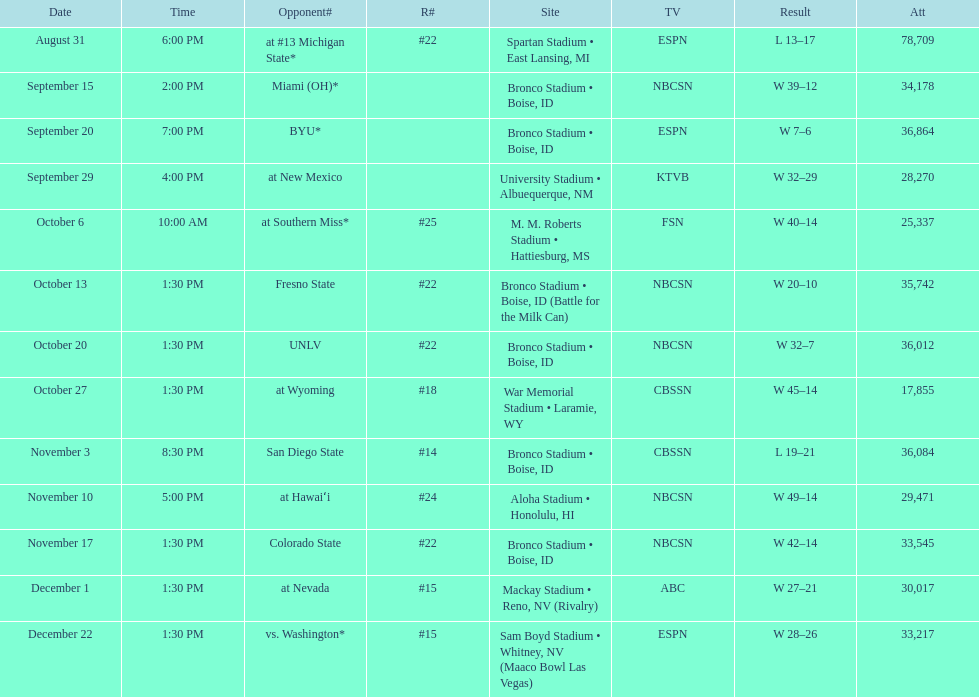What is the total number of games played at bronco stadium? 6. 